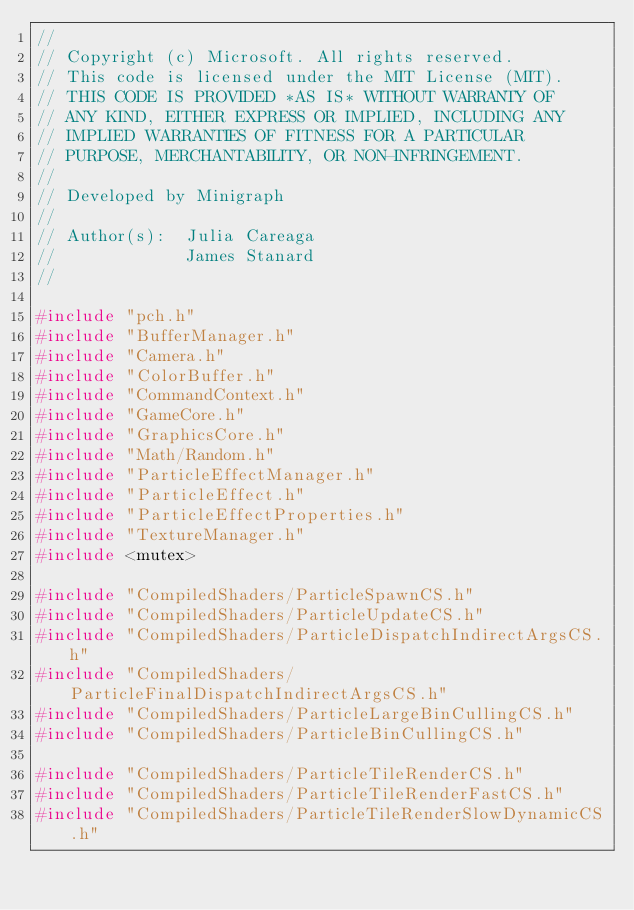Convert code to text. <code><loc_0><loc_0><loc_500><loc_500><_C++_>//
// Copyright (c) Microsoft. All rights reserved.
// This code is licensed under the MIT License (MIT).
// THIS CODE IS PROVIDED *AS IS* WITHOUT WARRANTY OF
// ANY KIND, EITHER EXPRESS OR IMPLIED, INCLUDING ANY
// IMPLIED WARRANTIES OF FITNESS FOR A PARTICULAR
// PURPOSE, MERCHANTABILITY, OR NON-INFRINGEMENT.
//
// Developed by Minigraph
//
// Author(s):  Julia Careaga
//             James Stanard
//

#include "pch.h"
#include "BufferManager.h"
#include "Camera.h"
#include "ColorBuffer.h"
#include "CommandContext.h"
#include "GameCore.h"
#include "GraphicsCore.h"
#include "Math/Random.h"
#include "ParticleEffectManager.h"
#include "ParticleEffect.h"
#include "ParticleEffectProperties.h"
#include "TextureManager.h"
#include <mutex>

#include "CompiledShaders/ParticleSpawnCS.h"
#include "CompiledShaders/ParticleUpdateCS.h"
#include "CompiledShaders/ParticleDispatchIndirectArgsCS.h"
#include "CompiledShaders/ParticleFinalDispatchIndirectArgsCS.h"
#include "CompiledShaders/ParticleLargeBinCullingCS.h"
#include "CompiledShaders/ParticleBinCullingCS.h"

#include "CompiledShaders/ParticleTileRenderCS.h"
#include "CompiledShaders/ParticleTileRenderFastCS.h"
#include "CompiledShaders/ParticleTileRenderSlowDynamicCS.h"</code> 